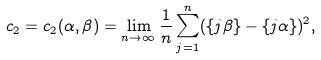Convert formula to latex. <formula><loc_0><loc_0><loc_500><loc_500>c _ { 2 } = c _ { 2 } ( \alpha , \beta ) = \lim _ { n \to \infty } \frac { 1 } { n } \sum _ { j = 1 } ^ { n } ( \{ j \beta \} - \{ j \alpha \} ) ^ { 2 } ,</formula> 